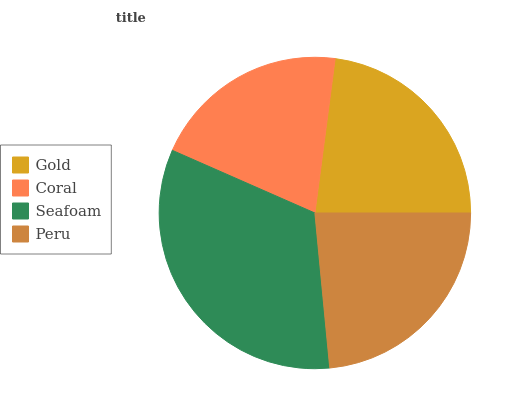Is Coral the minimum?
Answer yes or no. Yes. Is Seafoam the maximum?
Answer yes or no. Yes. Is Seafoam the minimum?
Answer yes or no. No. Is Coral the maximum?
Answer yes or no. No. Is Seafoam greater than Coral?
Answer yes or no. Yes. Is Coral less than Seafoam?
Answer yes or no. Yes. Is Coral greater than Seafoam?
Answer yes or no. No. Is Seafoam less than Coral?
Answer yes or no. No. Is Peru the high median?
Answer yes or no. Yes. Is Gold the low median?
Answer yes or no. Yes. Is Seafoam the high median?
Answer yes or no. No. Is Seafoam the low median?
Answer yes or no. No. 